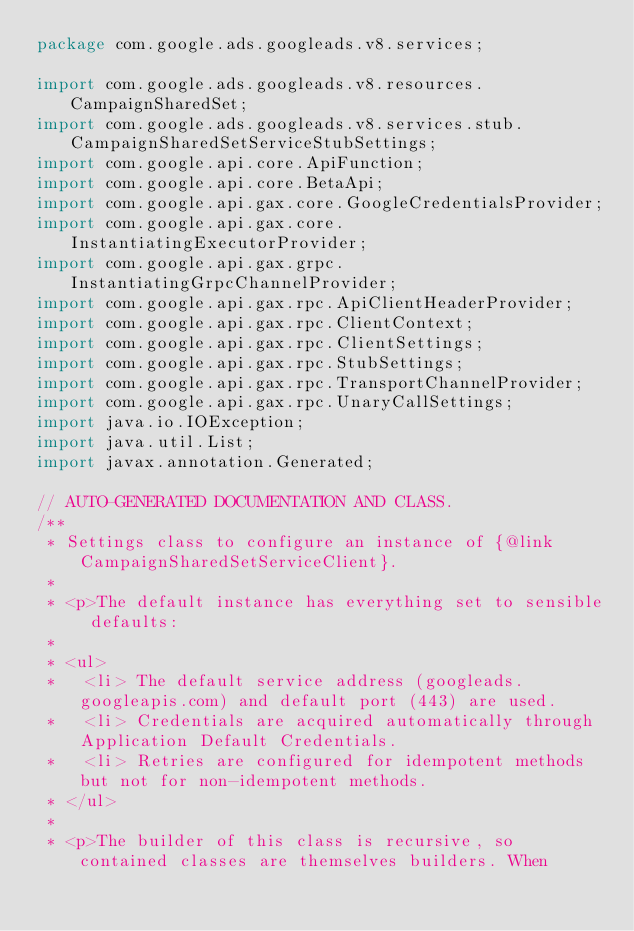Convert code to text. <code><loc_0><loc_0><loc_500><loc_500><_Java_>package com.google.ads.googleads.v8.services;

import com.google.ads.googleads.v8.resources.CampaignSharedSet;
import com.google.ads.googleads.v8.services.stub.CampaignSharedSetServiceStubSettings;
import com.google.api.core.ApiFunction;
import com.google.api.core.BetaApi;
import com.google.api.gax.core.GoogleCredentialsProvider;
import com.google.api.gax.core.InstantiatingExecutorProvider;
import com.google.api.gax.grpc.InstantiatingGrpcChannelProvider;
import com.google.api.gax.rpc.ApiClientHeaderProvider;
import com.google.api.gax.rpc.ClientContext;
import com.google.api.gax.rpc.ClientSettings;
import com.google.api.gax.rpc.StubSettings;
import com.google.api.gax.rpc.TransportChannelProvider;
import com.google.api.gax.rpc.UnaryCallSettings;
import java.io.IOException;
import java.util.List;
import javax.annotation.Generated;

// AUTO-GENERATED DOCUMENTATION AND CLASS.
/**
 * Settings class to configure an instance of {@link CampaignSharedSetServiceClient}.
 *
 * <p>The default instance has everything set to sensible defaults:
 *
 * <ul>
 *   <li> The default service address (googleads.googleapis.com) and default port (443) are used.
 *   <li> Credentials are acquired automatically through Application Default Credentials.
 *   <li> Retries are configured for idempotent methods but not for non-idempotent methods.
 * </ul>
 *
 * <p>The builder of this class is recursive, so contained classes are themselves builders. When</code> 